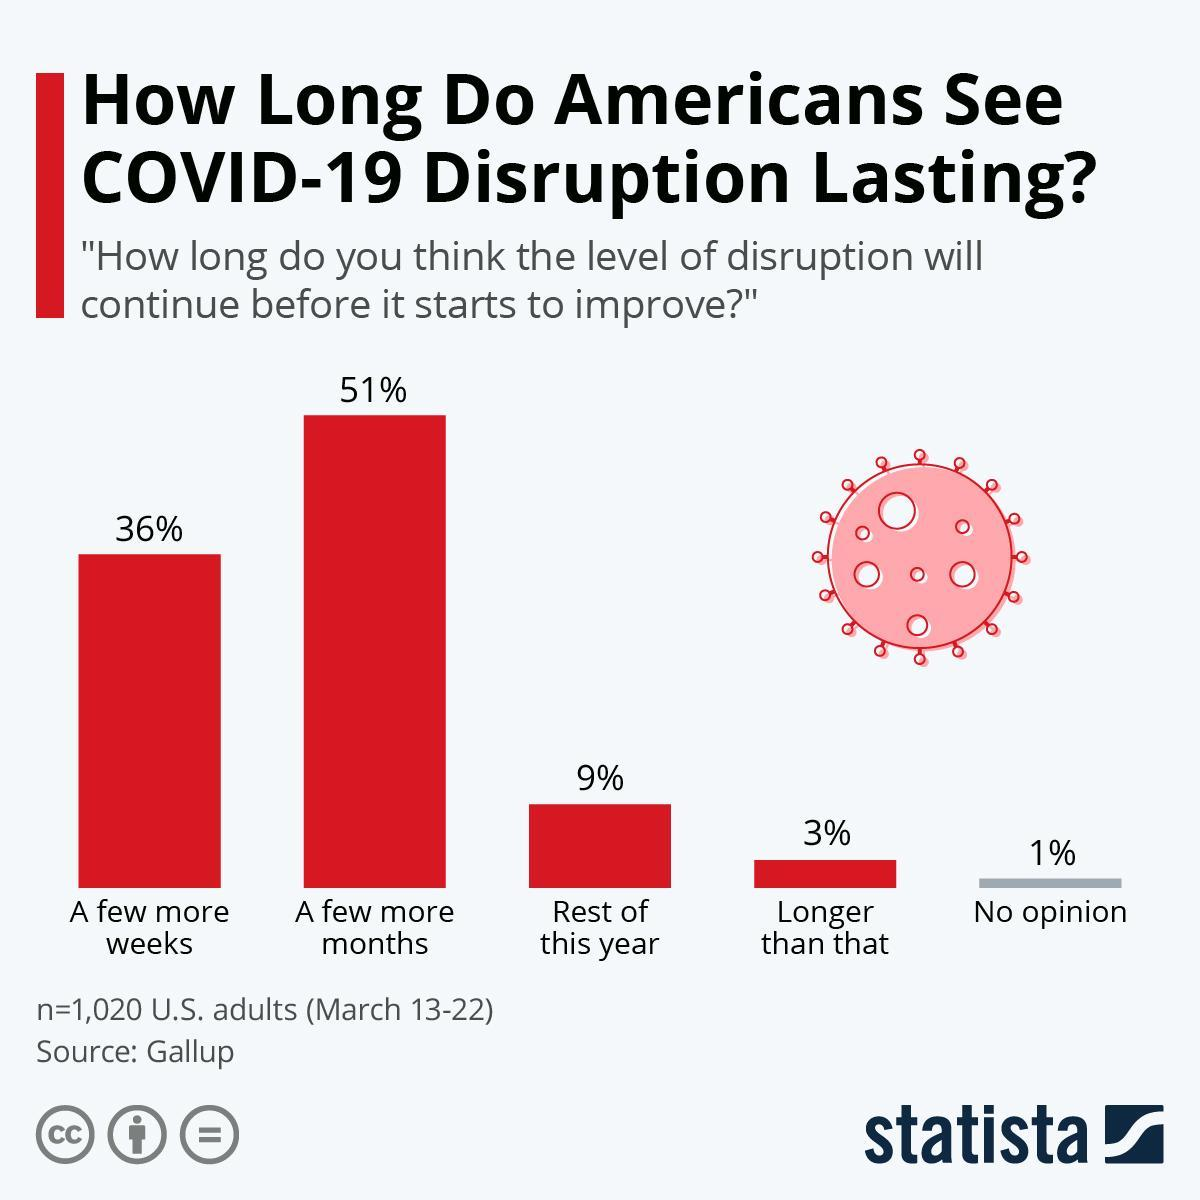How many people voted for the opinion "Longer than that"?
Answer the question with a short phrase. 30.6 Which is the opinion which has third highest no of votes for duration of corona? Rest of this year Which is the opinion which has second highest no of votes? A few more weeks What is the inverse of the percentage of people who have "No Opinion"? 99 What is the percentage difference in first and second opinion? 15 